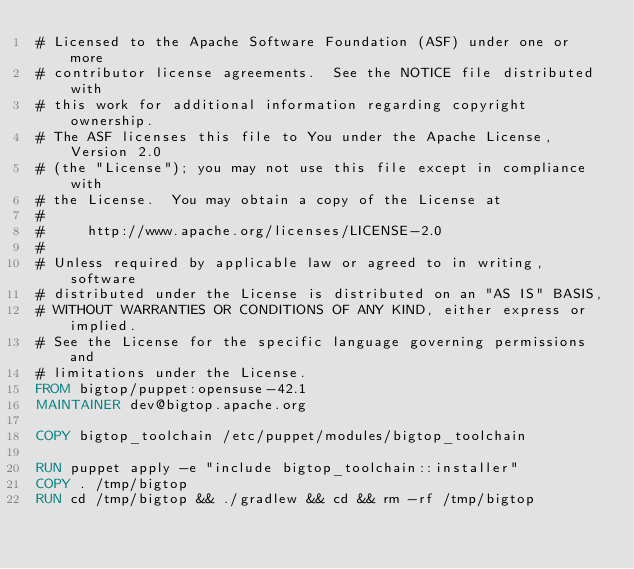<code> <loc_0><loc_0><loc_500><loc_500><_Dockerfile_># Licensed to the Apache Software Foundation (ASF) under one or more
# contributor license agreements.  See the NOTICE file distributed with
# this work for additional information regarding copyright ownership.
# The ASF licenses this file to You under the Apache License, Version 2.0
# (the "License"); you may not use this file except in compliance with
# the License.  You may obtain a copy of the License at
#
#     http://www.apache.org/licenses/LICENSE-2.0
#
# Unless required by applicable law or agreed to in writing, software
# distributed under the License is distributed on an "AS IS" BASIS,
# WITHOUT WARRANTIES OR CONDITIONS OF ANY KIND, either express or implied.
# See the License for the specific language governing permissions and
# limitations under the License.
FROM bigtop/puppet:opensuse-42.1
MAINTAINER dev@bigtop.apache.org

COPY bigtop_toolchain /etc/puppet/modules/bigtop_toolchain

RUN puppet apply -e "include bigtop_toolchain::installer"
COPY . /tmp/bigtop
RUN cd /tmp/bigtop && ./gradlew && cd && rm -rf /tmp/bigtop
</code> 